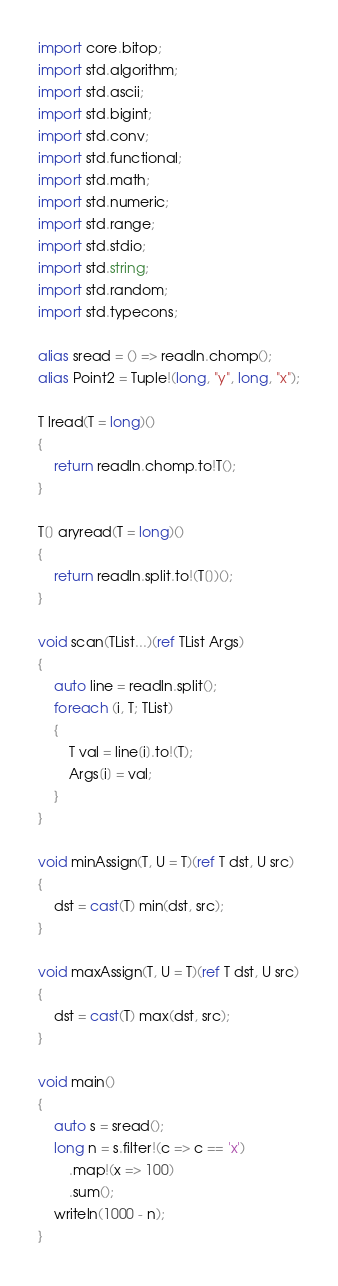Convert code to text. <code><loc_0><loc_0><loc_500><loc_500><_D_>import core.bitop;
import std.algorithm;
import std.ascii;
import std.bigint;
import std.conv;
import std.functional;
import std.math;
import std.numeric;
import std.range;
import std.stdio;
import std.string;
import std.random;
import std.typecons;

alias sread = () => readln.chomp();
alias Point2 = Tuple!(long, "y", long, "x");

T lread(T = long)()
{
    return readln.chomp.to!T();
}

T[] aryread(T = long)()
{
    return readln.split.to!(T[])();
}

void scan(TList...)(ref TList Args)
{
    auto line = readln.split();
    foreach (i, T; TList)
    {
        T val = line[i].to!(T);
        Args[i] = val;
    }
}

void minAssign(T, U = T)(ref T dst, U src)
{
    dst = cast(T) min(dst, src);
}

void maxAssign(T, U = T)(ref T dst, U src)
{
    dst = cast(T) max(dst, src);
}

void main()
{
    auto s = sread();
    long n = s.filter!(c => c == 'x')
        .map!(x => 100)
        .sum();
    writeln(1000 - n);
}
</code> 